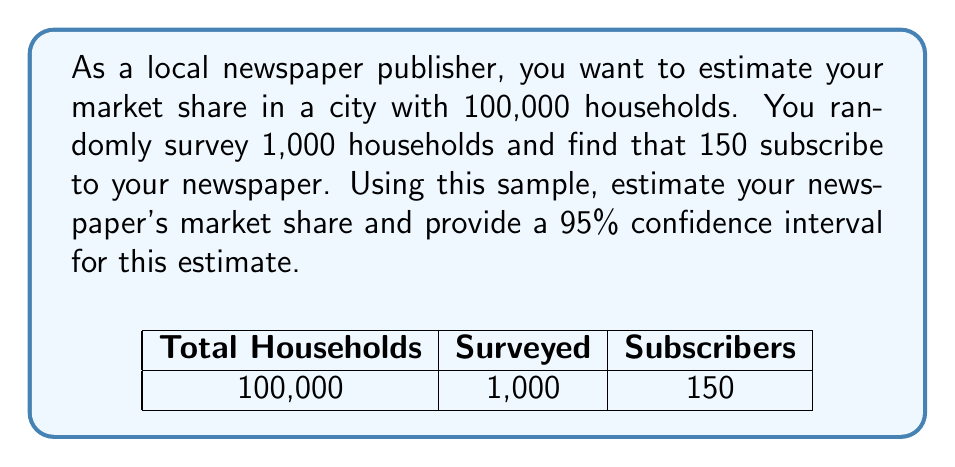Help me with this question. Let's approach this step-by-step:

1) First, we calculate the point estimate of the market share:
   $$\hat{p} = \frac{\text{Number of subscribers in sample}}{\text{Total sample size}} = \frac{150}{1000} = 0.15 = 15\%$$

2) For the confidence interval, we need the standard error of the proportion:
   $$SE = \sqrt{\frac{\hat{p}(1-\hat{p})}{n}} = \sqrt{\frac{0.15(1-0.15)}{1000}} = \sqrt{\frac{0.1275}{1000}} \approx 0.0113$$

3) For a 95% confidence interval, we use a z-score of 1.96:
   $$\text{Margin of Error} = 1.96 \times SE = 1.96 \times 0.0113 \approx 0.0221$$

4) The 95% confidence interval is:
   $$(\hat{p} - \text{Margin of Error}, \hat{p} + \text{Margin of Error})$$
   $$(0.15 - 0.0221, 0.15 + 0.0221)$$
   $$(0.1279, 0.1721)$$

5) Converting to percentages:
   $$(12.79\%, 17.21\%)$$

Therefore, we estimate the market share to be 15%, and we are 95% confident that the true market share is between 12.79% and 17.21%.
Answer: 15% (95% CI: 12.79% - 17.21%) 